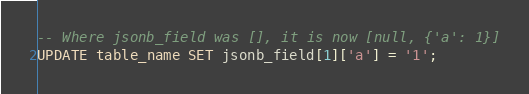<code> <loc_0><loc_0><loc_500><loc_500><_SQL_>
-- Where jsonb_field was [], it is now [null, {'a': 1}]
UPDATE table_name SET jsonb_field[1]['a'] = '1';
</code> 